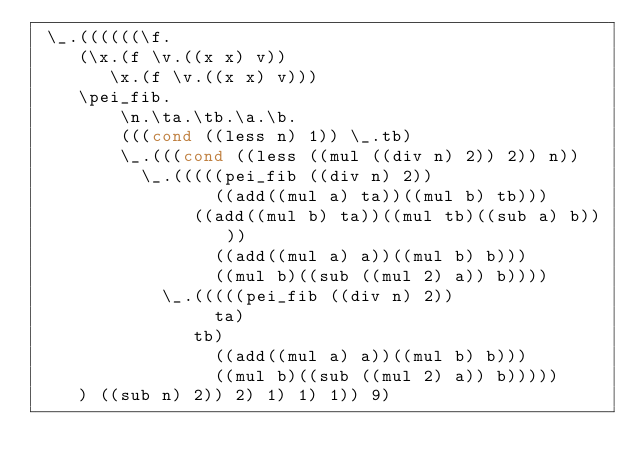Convert code to text. <code><loc_0><loc_0><loc_500><loc_500><_Scheme_> \_.((((((\f.
    (\x.(f \v.((x x) v))
       \x.(f \v.((x x) v)))
		\pei_fib.
        \n.\ta.\tb.\a.\b.
        (((cond ((less n) 1)) \_.tb)
        \_.(((cond ((less ((mul ((div n) 2)) 2)) n))
        	\_.(((((pei_fib ((div n) 2))
                 ((add((mul a) ta))((mul b) tb)))
            	 ((add((mul b) ta))((mul tb)((sub a) b))))
                 ((add((mul a) a))((mul b) b)))
                 ((mul b)((sub ((mul 2) a)) b))))
            \_.(((((pei_fib ((div n) 2))
                 ta)
            	 tb)
                 ((add((mul a) a))((mul b) b)))
                 ((mul b)((sub ((mul 2) a)) b)))))
    ) ((sub n) 2)) 2) 1) 1) 1)) 9)</code> 